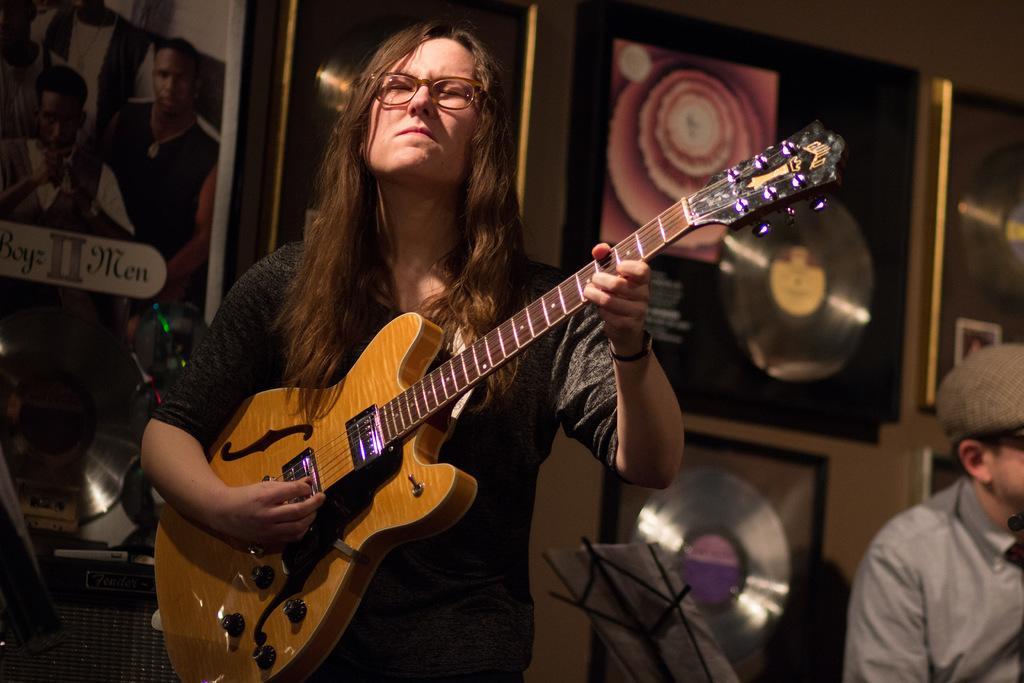Can you describe this image briefly? This is the picture in a room, the person is holding a guitar to the right side of the man there is a other person sitting on chair. background of these people there is a wall with photos and some music systems. 